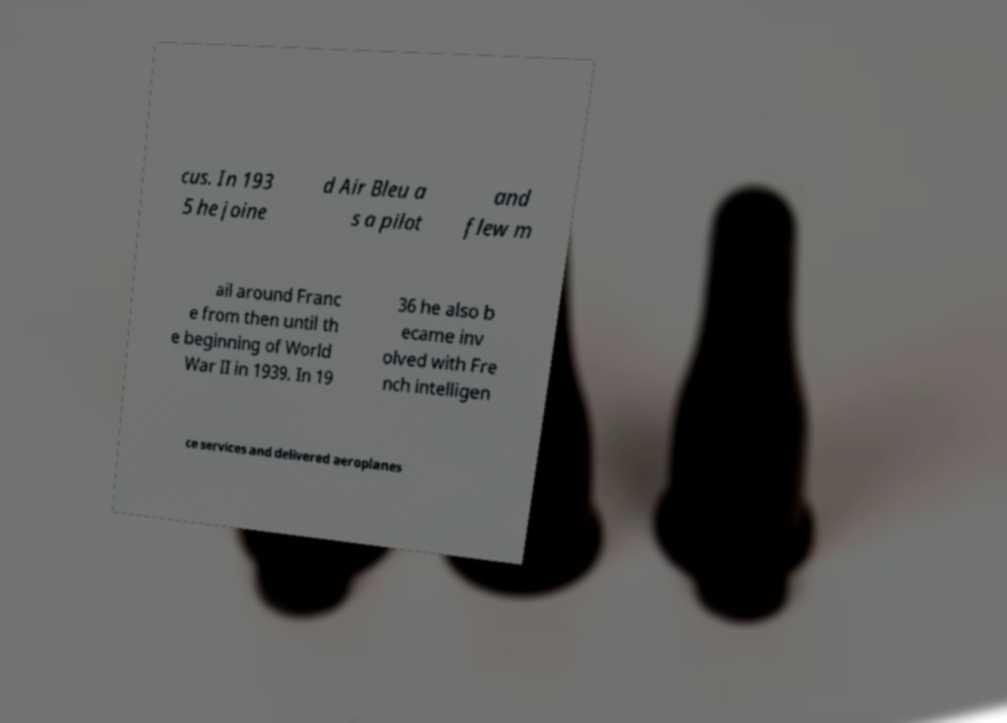Can you read and provide the text displayed in the image?This photo seems to have some interesting text. Can you extract and type it out for me? cus. In 193 5 he joine d Air Bleu a s a pilot and flew m ail around Franc e from then until th e beginning of World War II in 1939. In 19 36 he also b ecame inv olved with Fre nch intelligen ce services and delivered aeroplanes 